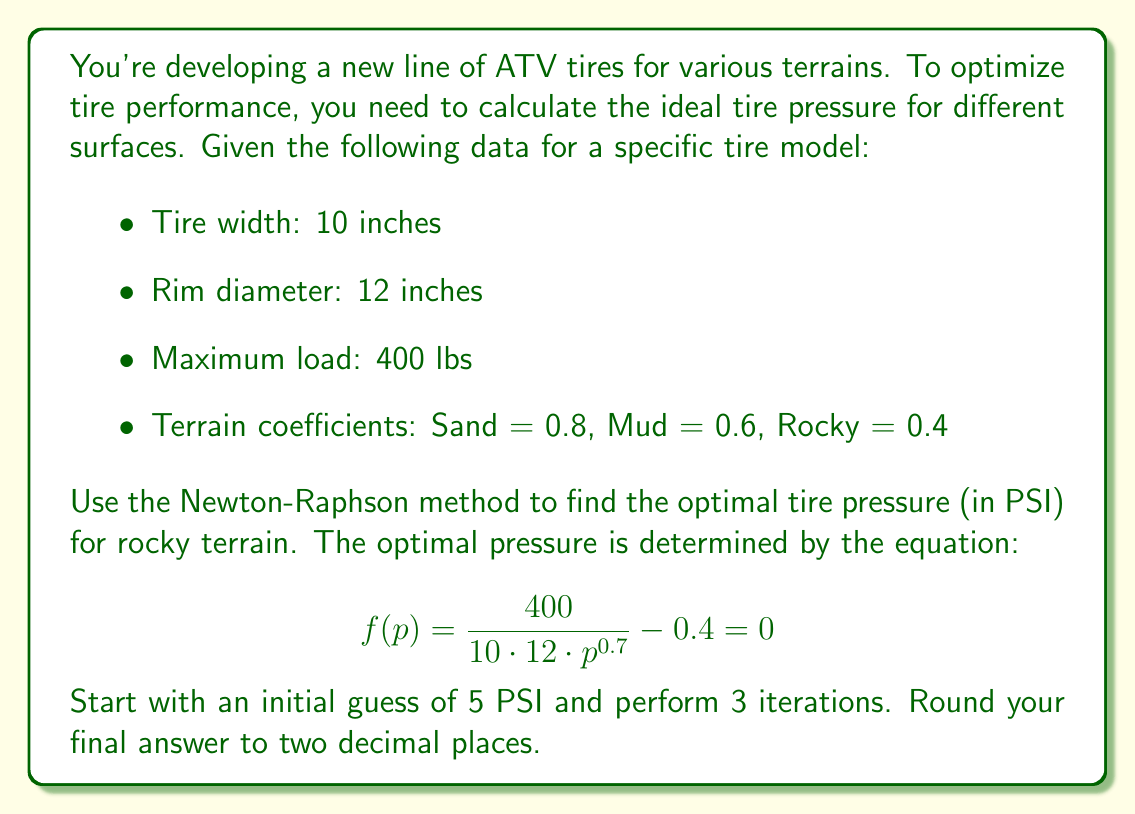Provide a solution to this math problem. To solve this problem, we'll use the Newton-Raphson method, which is given by the formula:

$$ p_{n+1} = p_n - \frac{f(p_n)}{f'(p_n)} $$

Where $f(p)$ is our function and $f'(p)$ is its derivative.

First, let's derive $f'(p)$:

$$ f'(p) = -0.7 \cdot \frac{400}{10 \cdot 12 \cdot p^{1.7}} $$

Now, we'll perform 3 iterations of the Newton-Raphson method:

Iteration 1:
$$ f(5) = \frac{400}{10 \cdot 12 \cdot 5^{0.7}} - 0.4 = 0.3849 $$
$$ f'(5) = -0.7 \cdot \frac{400}{10 \cdot 12 \cdot 5^{1.7}} = -0.1078 $$
$$ p_1 = 5 - \frac{0.3849}{-0.1078} = 8.5696 $$

Iteration 2:
$$ f(8.5696) = \frac{400}{10 \cdot 12 \cdot 8.5696^{0.7}} - 0.4 = 0.0183 $$
$$ f'(8.5696) = -0.7 \cdot \frac{400}{10 \cdot 12 \cdot 8.5696^{1.7}} = -0.0455 $$
$$ p_2 = 8.5696 - \frac{0.0183}{-0.0455} = 8.9715 $$

Iteration 3:
$$ f(8.9715) = \frac{400}{10 \cdot 12 \cdot 8.9715^{0.7}} - 0.4 = 0.0001 $$
$$ f'(8.9715) = -0.7 \cdot \frac{400}{10 \cdot 12 \cdot 8.9715^{1.7}} = -0.0424 $$
$$ p_3 = 8.9715 - \frac{0.0001}{-0.0424} = 8.9717 $$

Rounding to two decimal places, we get 8.97 PSI.
Answer: 8.97 PSI 